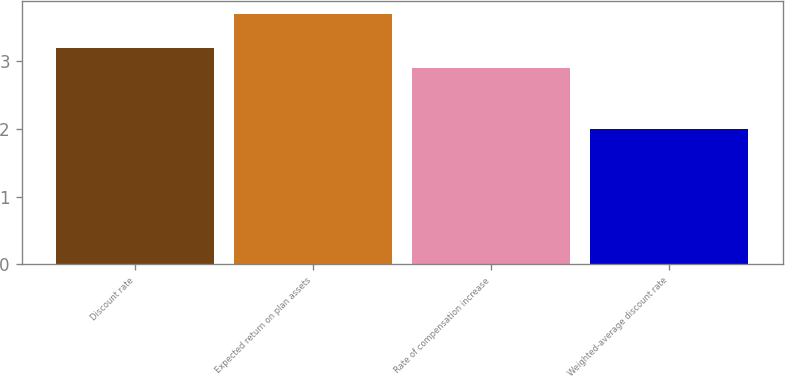Convert chart to OTSL. <chart><loc_0><loc_0><loc_500><loc_500><bar_chart><fcel>Discount rate<fcel>Expected return on plan assets<fcel>Rate of compensation increase<fcel>Weighted-average discount rate<nl><fcel>3.2<fcel>3.7<fcel>2.9<fcel>2<nl></chart> 